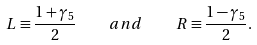Convert formula to latex. <formula><loc_0><loc_0><loc_500><loc_500>L \equiv \frac { 1 + \gamma _ { 5 } } { 2 } \quad a n d \quad R \equiv \frac { 1 - \gamma _ { 5 } } { 2 } .</formula> 